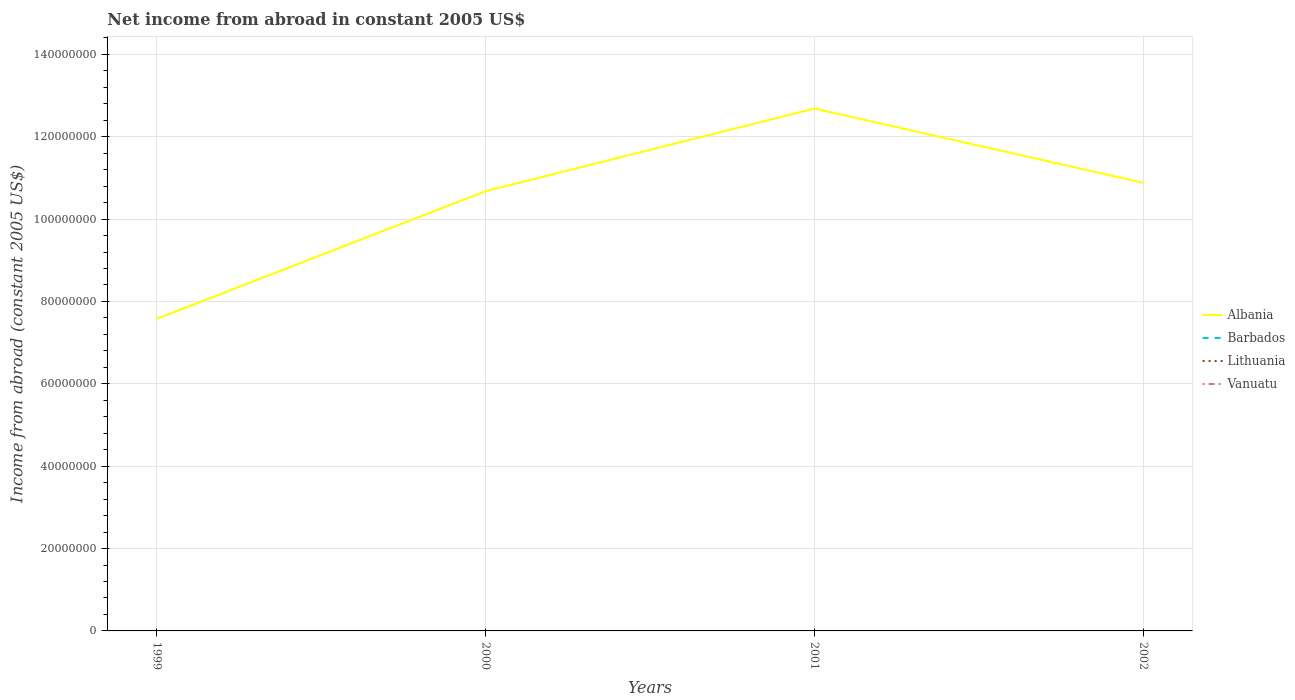What is the total net income from abroad in Albania in the graph?
Provide a succinct answer. -2.03e+06. What is the difference between the highest and the second highest net income from abroad in Albania?
Offer a very short reply. 5.11e+07. Is the net income from abroad in Albania strictly greater than the net income from abroad in Vanuatu over the years?
Give a very brief answer. No. How many years are there in the graph?
Your answer should be compact. 4. Are the values on the major ticks of Y-axis written in scientific E-notation?
Ensure brevity in your answer.  No. How many legend labels are there?
Keep it short and to the point. 4. What is the title of the graph?
Keep it short and to the point. Net income from abroad in constant 2005 US$. What is the label or title of the X-axis?
Ensure brevity in your answer.  Years. What is the label or title of the Y-axis?
Make the answer very short. Income from abroad (constant 2005 US$). What is the Income from abroad (constant 2005 US$) in Albania in 1999?
Your answer should be very brief. 7.58e+07. What is the Income from abroad (constant 2005 US$) in Barbados in 1999?
Offer a very short reply. 0. What is the Income from abroad (constant 2005 US$) in Vanuatu in 1999?
Your answer should be compact. 0. What is the Income from abroad (constant 2005 US$) of Albania in 2000?
Your answer should be compact. 1.07e+08. What is the Income from abroad (constant 2005 US$) of Albania in 2001?
Ensure brevity in your answer.  1.27e+08. What is the Income from abroad (constant 2005 US$) in Barbados in 2001?
Give a very brief answer. 0. What is the Income from abroad (constant 2005 US$) in Lithuania in 2001?
Provide a short and direct response. 0. What is the Income from abroad (constant 2005 US$) in Vanuatu in 2001?
Give a very brief answer. 0. What is the Income from abroad (constant 2005 US$) in Albania in 2002?
Ensure brevity in your answer.  1.09e+08. What is the Income from abroad (constant 2005 US$) in Lithuania in 2002?
Your answer should be very brief. 0. What is the Income from abroad (constant 2005 US$) of Vanuatu in 2002?
Give a very brief answer. 0. Across all years, what is the maximum Income from abroad (constant 2005 US$) in Albania?
Ensure brevity in your answer.  1.27e+08. Across all years, what is the minimum Income from abroad (constant 2005 US$) in Albania?
Your answer should be compact. 7.58e+07. What is the total Income from abroad (constant 2005 US$) in Albania in the graph?
Ensure brevity in your answer.  4.18e+08. What is the total Income from abroad (constant 2005 US$) in Vanuatu in the graph?
Provide a succinct answer. 0. What is the difference between the Income from abroad (constant 2005 US$) of Albania in 1999 and that in 2000?
Provide a short and direct response. -3.10e+07. What is the difference between the Income from abroad (constant 2005 US$) in Albania in 1999 and that in 2001?
Offer a terse response. -5.11e+07. What is the difference between the Income from abroad (constant 2005 US$) in Albania in 1999 and that in 2002?
Provide a succinct answer. -3.30e+07. What is the difference between the Income from abroad (constant 2005 US$) in Albania in 2000 and that in 2001?
Ensure brevity in your answer.  -2.01e+07. What is the difference between the Income from abroad (constant 2005 US$) in Albania in 2000 and that in 2002?
Offer a very short reply. -2.03e+06. What is the difference between the Income from abroad (constant 2005 US$) in Albania in 2001 and that in 2002?
Ensure brevity in your answer.  1.80e+07. What is the average Income from abroad (constant 2005 US$) of Albania per year?
Make the answer very short. 1.05e+08. What is the average Income from abroad (constant 2005 US$) in Barbados per year?
Give a very brief answer. 0. What is the average Income from abroad (constant 2005 US$) in Lithuania per year?
Your answer should be very brief. 0. What is the average Income from abroad (constant 2005 US$) of Vanuatu per year?
Your answer should be very brief. 0. What is the ratio of the Income from abroad (constant 2005 US$) of Albania in 1999 to that in 2000?
Your answer should be very brief. 0.71. What is the ratio of the Income from abroad (constant 2005 US$) of Albania in 1999 to that in 2001?
Offer a very short reply. 0.6. What is the ratio of the Income from abroad (constant 2005 US$) of Albania in 1999 to that in 2002?
Give a very brief answer. 0.7. What is the ratio of the Income from abroad (constant 2005 US$) of Albania in 2000 to that in 2001?
Your answer should be very brief. 0.84. What is the ratio of the Income from abroad (constant 2005 US$) of Albania in 2000 to that in 2002?
Give a very brief answer. 0.98. What is the ratio of the Income from abroad (constant 2005 US$) of Albania in 2001 to that in 2002?
Offer a terse response. 1.17. What is the difference between the highest and the second highest Income from abroad (constant 2005 US$) of Albania?
Ensure brevity in your answer.  1.80e+07. What is the difference between the highest and the lowest Income from abroad (constant 2005 US$) of Albania?
Make the answer very short. 5.11e+07. 